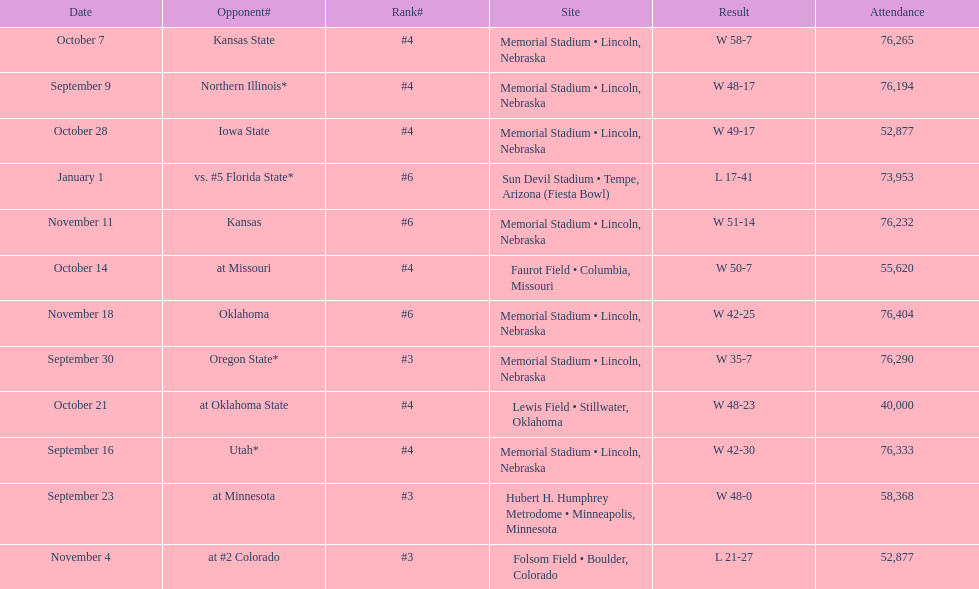How many games did they win by more than 7? 10. 